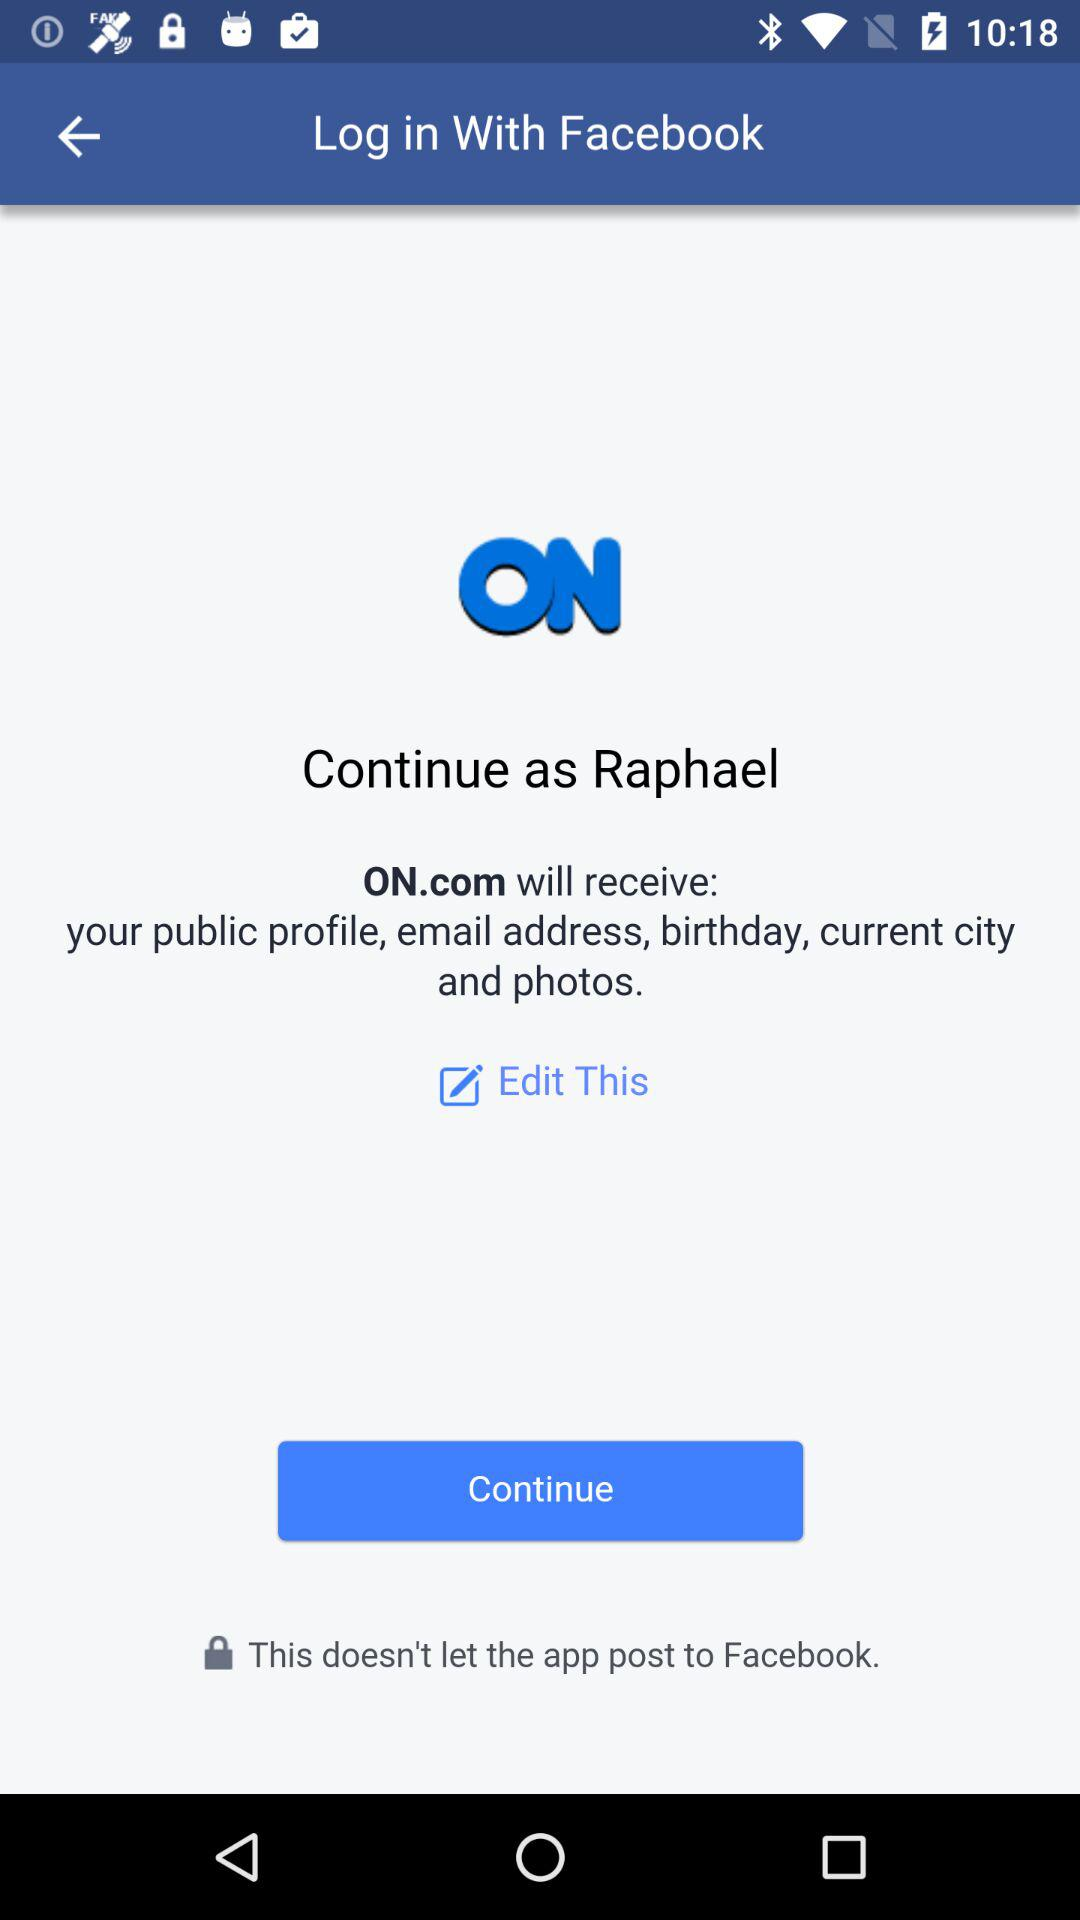How can we log in? You can log in with "Facebook". 